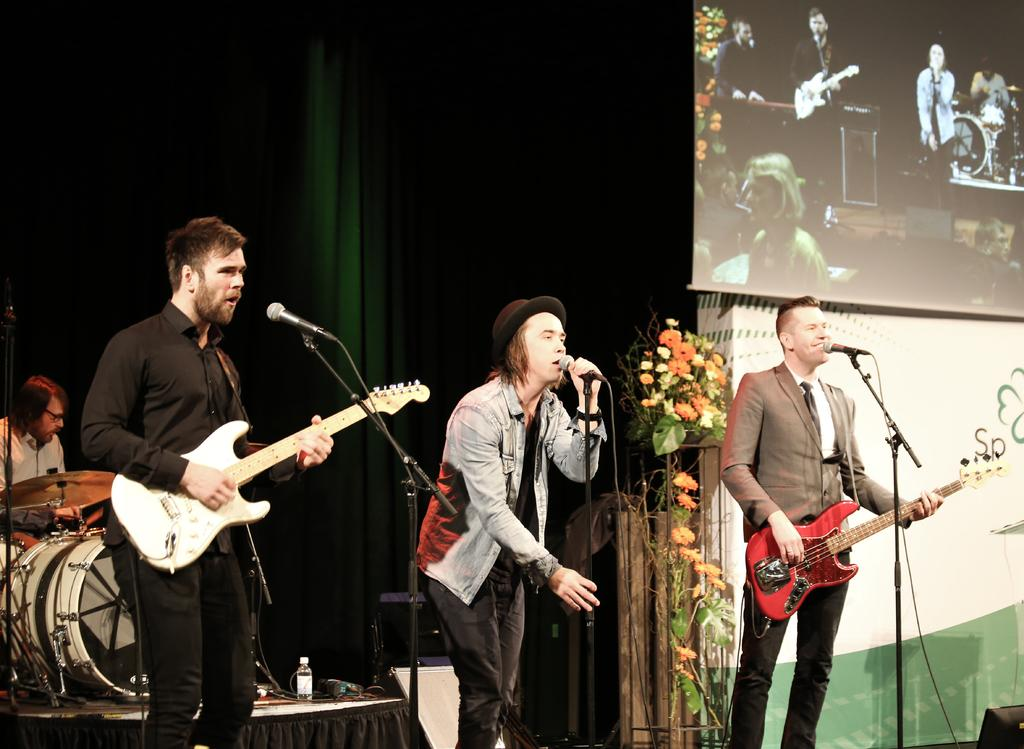How many people are in the image? There are three guys in the image. What are the guys doing in the image? The guys are singing and playing guitar. What is in front of the guys? There is a microphone in front of them. What color is the background in the image? The background is green in color. What type of plant is growing on the guitar in the image? There is no plant growing on the guitar in the image. What kind of cheese is being used as a prop in the image? There is no cheese present in the image. 